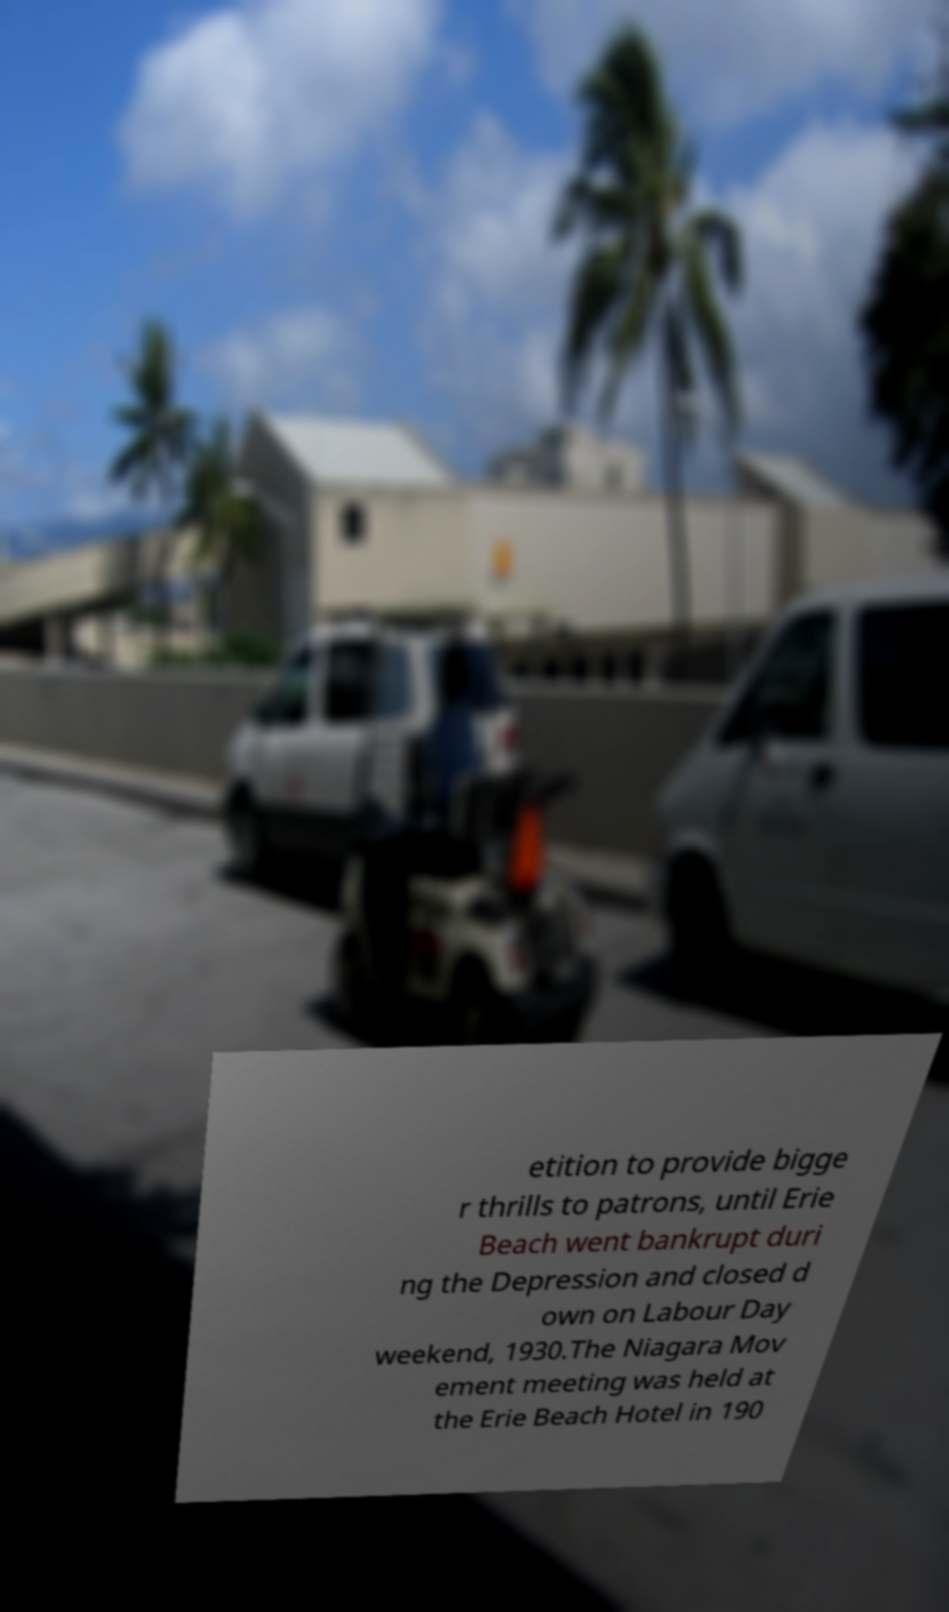Can you read and provide the text displayed in the image?This photo seems to have some interesting text. Can you extract and type it out for me? etition to provide bigge r thrills to patrons, until Erie Beach went bankrupt duri ng the Depression and closed d own on Labour Day weekend, 1930.The Niagara Mov ement meeting was held at the Erie Beach Hotel in 190 